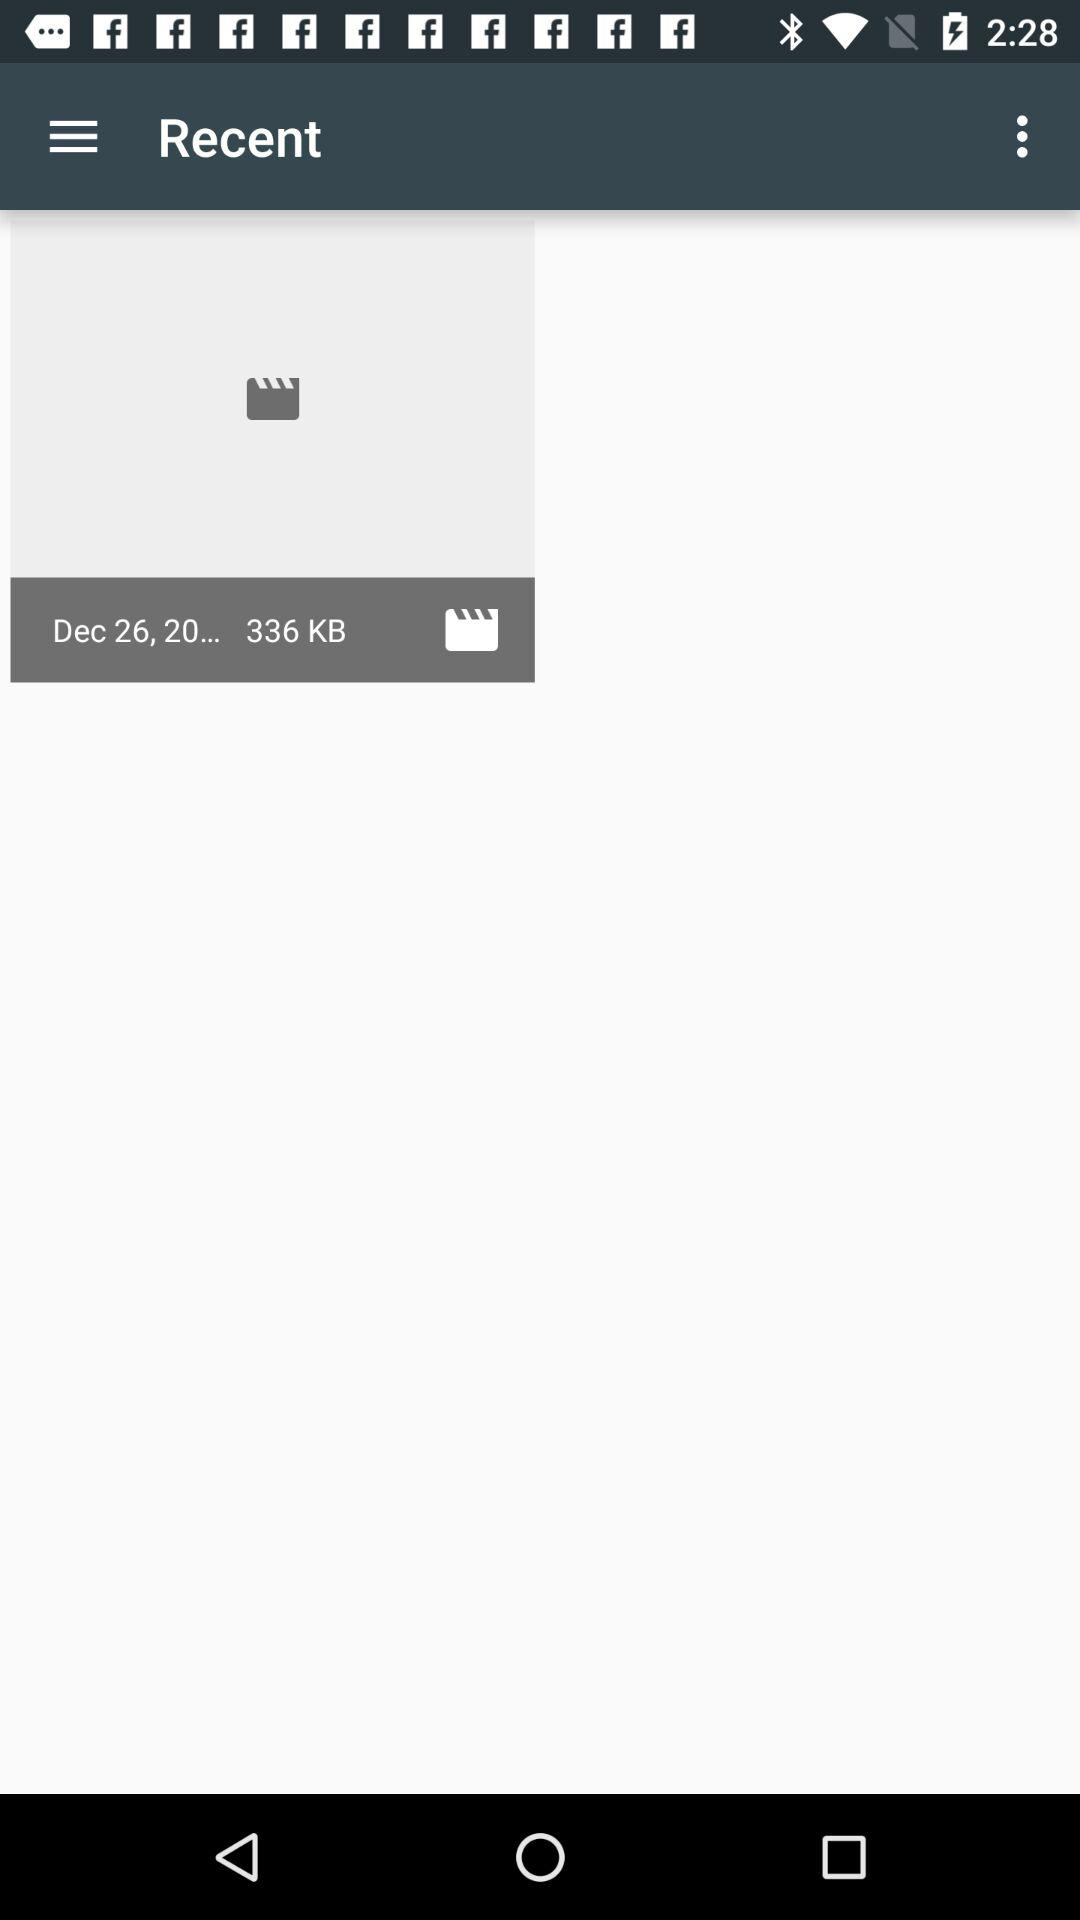What is the recent tab?
When the provided information is insufficient, respond with <no answer>. <no answer> 